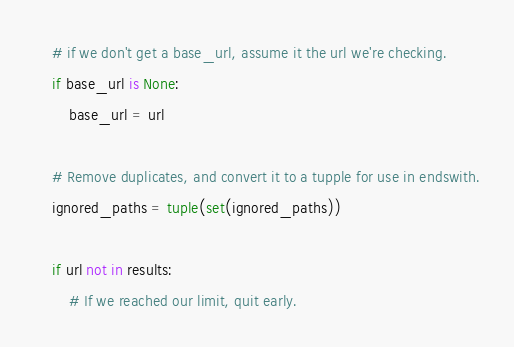Convert code to text. <code><loc_0><loc_0><loc_500><loc_500><_Python_>    # if we don't get a base_url, assume it the url we're checking.
    if base_url is None:
        base_url = url

    # Remove duplicates, and convert it to a tupple for use in endswith.
    ignored_paths = tuple(set(ignored_paths))

    if url not in results:
        # If we reached our limit, quit early.</code> 